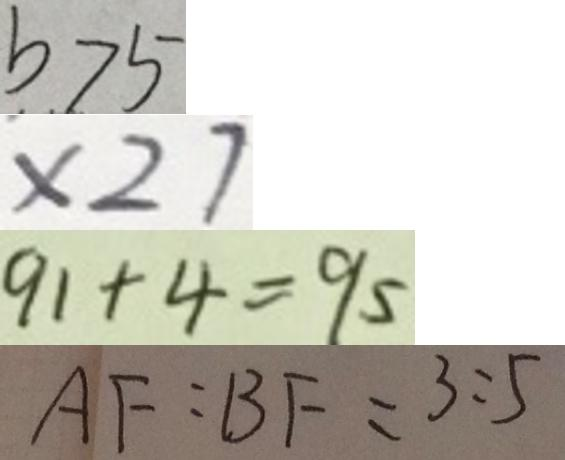Convert formula to latex. <formula><loc_0><loc_0><loc_500><loc_500>b > 5 
 \times 2 7 
 9 1 + 4 = 9 5 
 A F : B F = 3 : 5</formula> 